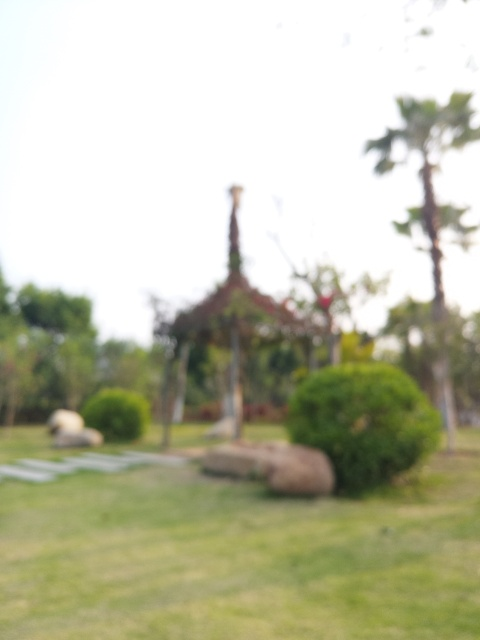What might be the reason this photo is out of focus? The photo could be out of focus due to several factors: the camera's autofocus might have malfunctioned or wasn't set correctly, the photographer might have moved while taking the picture, or there could have been an error in lens calibration. It's also possible that the shallow depth of field was intentional for artistic effect, but given the context, that seems less likely. How can this focusing issue be fixed in future photos? To prevent focusing issues in future photos, ensure the camera's autofocus is engaged and targeting the right area before taking the picture. Use a tripod to avoid camera shake, double-check lens calibration, and increase the depth of field by adjusting the aperture if you want more of the scene in focus. 